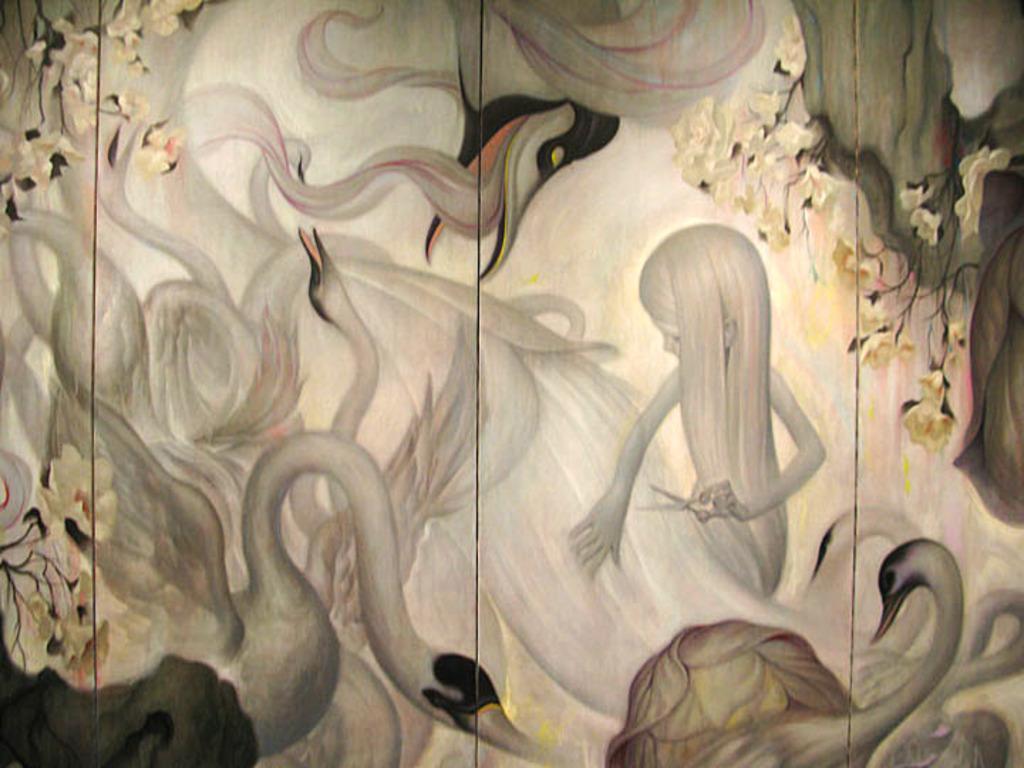Can you describe this image briefly? There are many images of the swans are drawn on a wall and in between the swans there is a girl holding the scissors. 